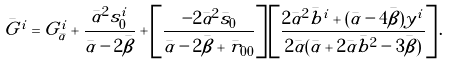<formula> <loc_0><loc_0><loc_500><loc_500>\bar { G } ^ { i } = G ^ { i } _ { \bar { \alpha } } + \frac { \bar { \alpha } ^ { 2 } s ^ { i } _ { 0 } } { \bar { \alpha } - 2 \bar { \beta } } + \left [ \frac { - 2 \bar { \alpha } ^ { 2 } \bar { s } _ { 0 } } { \bar { \alpha } - 2 \bar { \beta } + \bar { r } _ { 0 0 } } \right ] \left [ \frac { 2 \bar { \alpha } ^ { 2 } \bar { b } ^ { i } + ( \bar { \alpha } - 4 \bar { \beta } ) y ^ { i } } { 2 \bar { \alpha } ( \bar { \alpha } + 2 \bar { \alpha } \bar { b } ^ { 2 } - 3 \bar { \beta } ) } \right ] .</formula> 